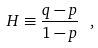<formula> <loc_0><loc_0><loc_500><loc_500>H \equiv \frac { q - p } { 1 - p } \ ,</formula> 